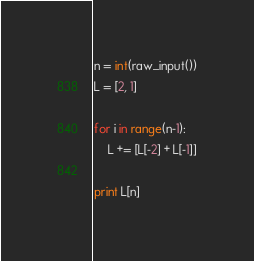<code> <loc_0><loc_0><loc_500><loc_500><_Python_>n = int(raw_input())
L = [2, 1]

for i in range(n-1):
    L += [L[-2] + L[-1]]

print L[n]
</code> 